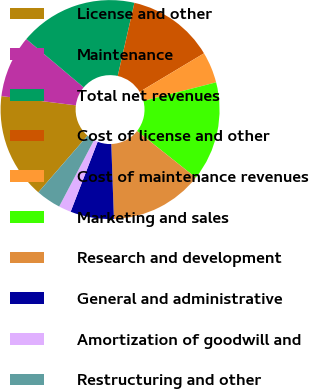Convert chart to OTSL. <chart><loc_0><loc_0><loc_500><loc_500><pie_chart><fcel>License and other<fcel>Maintenance<fcel>Total net revenues<fcel>Cost of license and other<fcel>Cost of maintenance revenues<fcel>Marketing and sales<fcel>Research and development<fcel>General and administrative<fcel>Amortization of goodwill and<fcel>Restructuring and other<nl><fcel>15.6%<fcel>9.17%<fcel>17.43%<fcel>12.84%<fcel>4.59%<fcel>14.68%<fcel>13.76%<fcel>6.42%<fcel>1.83%<fcel>3.67%<nl></chart> 